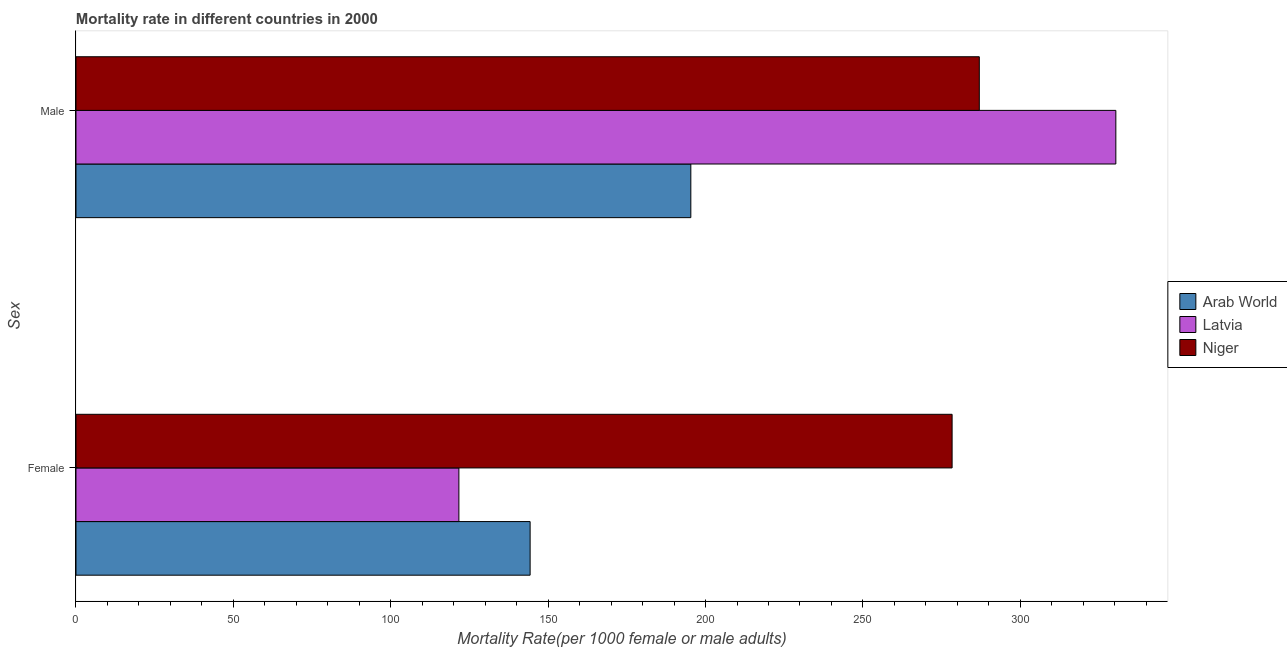How many different coloured bars are there?
Give a very brief answer. 3. How many groups of bars are there?
Ensure brevity in your answer.  2. Are the number of bars on each tick of the Y-axis equal?
Offer a very short reply. Yes. How many bars are there on the 1st tick from the bottom?
Make the answer very short. 3. What is the label of the 2nd group of bars from the top?
Your response must be concise. Female. What is the female mortality rate in Niger?
Your answer should be compact. 278.34. Across all countries, what is the maximum female mortality rate?
Your answer should be compact. 278.34. Across all countries, what is the minimum female mortality rate?
Give a very brief answer. 121.65. In which country was the female mortality rate maximum?
Ensure brevity in your answer.  Niger. In which country was the male mortality rate minimum?
Your response must be concise. Arab World. What is the total male mortality rate in the graph?
Offer a very short reply. 812.67. What is the difference between the female mortality rate in Arab World and that in Latvia?
Your response must be concise. 22.63. What is the difference between the male mortality rate in Niger and the female mortality rate in Latvia?
Keep it short and to the point. 165.34. What is the average female mortality rate per country?
Provide a succinct answer. 181.42. What is the difference between the male mortality rate and female mortality rate in Niger?
Offer a very short reply. 8.64. In how many countries, is the male mortality rate greater than 230 ?
Give a very brief answer. 2. What is the ratio of the female mortality rate in Latvia to that in Niger?
Your answer should be very brief. 0.44. In how many countries, is the male mortality rate greater than the average male mortality rate taken over all countries?
Offer a very short reply. 2. What does the 1st bar from the top in Male represents?
Offer a terse response. Niger. What does the 3rd bar from the bottom in Female represents?
Give a very brief answer. Niger. How many bars are there?
Your answer should be compact. 6. Are all the bars in the graph horizontal?
Give a very brief answer. Yes. What is the difference between two consecutive major ticks on the X-axis?
Provide a succinct answer. 50. Does the graph contain any zero values?
Provide a short and direct response. No. Does the graph contain grids?
Make the answer very short. No. What is the title of the graph?
Your answer should be compact. Mortality rate in different countries in 2000. What is the label or title of the X-axis?
Offer a very short reply. Mortality Rate(per 1000 female or male adults). What is the label or title of the Y-axis?
Offer a terse response. Sex. What is the Mortality Rate(per 1000 female or male adults) in Arab World in Female?
Your response must be concise. 144.28. What is the Mortality Rate(per 1000 female or male adults) of Latvia in Female?
Provide a short and direct response. 121.65. What is the Mortality Rate(per 1000 female or male adults) of Niger in Female?
Give a very brief answer. 278.34. What is the Mortality Rate(per 1000 female or male adults) of Arab World in Male?
Your answer should be very brief. 195.33. What is the Mortality Rate(per 1000 female or male adults) of Latvia in Male?
Keep it short and to the point. 330.36. What is the Mortality Rate(per 1000 female or male adults) of Niger in Male?
Ensure brevity in your answer.  286.98. Across all Sex, what is the maximum Mortality Rate(per 1000 female or male adults) of Arab World?
Provide a succinct answer. 195.33. Across all Sex, what is the maximum Mortality Rate(per 1000 female or male adults) of Latvia?
Offer a terse response. 330.36. Across all Sex, what is the maximum Mortality Rate(per 1000 female or male adults) in Niger?
Offer a terse response. 286.98. Across all Sex, what is the minimum Mortality Rate(per 1000 female or male adults) in Arab World?
Your answer should be compact. 144.28. Across all Sex, what is the minimum Mortality Rate(per 1000 female or male adults) in Latvia?
Provide a short and direct response. 121.65. Across all Sex, what is the minimum Mortality Rate(per 1000 female or male adults) in Niger?
Make the answer very short. 278.34. What is the total Mortality Rate(per 1000 female or male adults) in Arab World in the graph?
Make the answer very short. 339.61. What is the total Mortality Rate(per 1000 female or male adults) of Latvia in the graph?
Offer a terse response. 452.01. What is the total Mortality Rate(per 1000 female or male adults) of Niger in the graph?
Give a very brief answer. 565.32. What is the difference between the Mortality Rate(per 1000 female or male adults) of Arab World in Female and that in Male?
Keep it short and to the point. -51.05. What is the difference between the Mortality Rate(per 1000 female or male adults) of Latvia in Female and that in Male?
Your answer should be compact. -208.71. What is the difference between the Mortality Rate(per 1000 female or male adults) in Niger in Female and that in Male?
Your response must be concise. -8.64. What is the difference between the Mortality Rate(per 1000 female or male adults) in Arab World in Female and the Mortality Rate(per 1000 female or male adults) in Latvia in Male?
Your answer should be very brief. -186.08. What is the difference between the Mortality Rate(per 1000 female or male adults) of Arab World in Female and the Mortality Rate(per 1000 female or male adults) of Niger in Male?
Your answer should be very brief. -142.71. What is the difference between the Mortality Rate(per 1000 female or male adults) of Latvia in Female and the Mortality Rate(per 1000 female or male adults) of Niger in Male?
Ensure brevity in your answer.  -165.34. What is the average Mortality Rate(per 1000 female or male adults) in Arab World per Sex?
Keep it short and to the point. 169.8. What is the average Mortality Rate(per 1000 female or male adults) of Latvia per Sex?
Your answer should be very brief. 226. What is the average Mortality Rate(per 1000 female or male adults) in Niger per Sex?
Your answer should be very brief. 282.66. What is the difference between the Mortality Rate(per 1000 female or male adults) of Arab World and Mortality Rate(per 1000 female or male adults) of Latvia in Female?
Provide a short and direct response. 22.63. What is the difference between the Mortality Rate(per 1000 female or male adults) of Arab World and Mortality Rate(per 1000 female or male adults) of Niger in Female?
Your answer should be very brief. -134.06. What is the difference between the Mortality Rate(per 1000 female or male adults) of Latvia and Mortality Rate(per 1000 female or male adults) of Niger in Female?
Your answer should be very brief. -156.69. What is the difference between the Mortality Rate(per 1000 female or male adults) in Arab World and Mortality Rate(per 1000 female or male adults) in Latvia in Male?
Give a very brief answer. -135.03. What is the difference between the Mortality Rate(per 1000 female or male adults) in Arab World and Mortality Rate(per 1000 female or male adults) in Niger in Male?
Make the answer very short. -91.65. What is the difference between the Mortality Rate(per 1000 female or male adults) in Latvia and Mortality Rate(per 1000 female or male adults) in Niger in Male?
Keep it short and to the point. 43.38. What is the ratio of the Mortality Rate(per 1000 female or male adults) of Arab World in Female to that in Male?
Your response must be concise. 0.74. What is the ratio of the Mortality Rate(per 1000 female or male adults) of Latvia in Female to that in Male?
Offer a terse response. 0.37. What is the ratio of the Mortality Rate(per 1000 female or male adults) of Niger in Female to that in Male?
Your answer should be very brief. 0.97. What is the difference between the highest and the second highest Mortality Rate(per 1000 female or male adults) in Arab World?
Make the answer very short. 51.05. What is the difference between the highest and the second highest Mortality Rate(per 1000 female or male adults) of Latvia?
Ensure brevity in your answer.  208.71. What is the difference between the highest and the second highest Mortality Rate(per 1000 female or male adults) in Niger?
Offer a terse response. 8.64. What is the difference between the highest and the lowest Mortality Rate(per 1000 female or male adults) in Arab World?
Make the answer very short. 51.05. What is the difference between the highest and the lowest Mortality Rate(per 1000 female or male adults) of Latvia?
Provide a short and direct response. 208.71. What is the difference between the highest and the lowest Mortality Rate(per 1000 female or male adults) of Niger?
Make the answer very short. 8.64. 